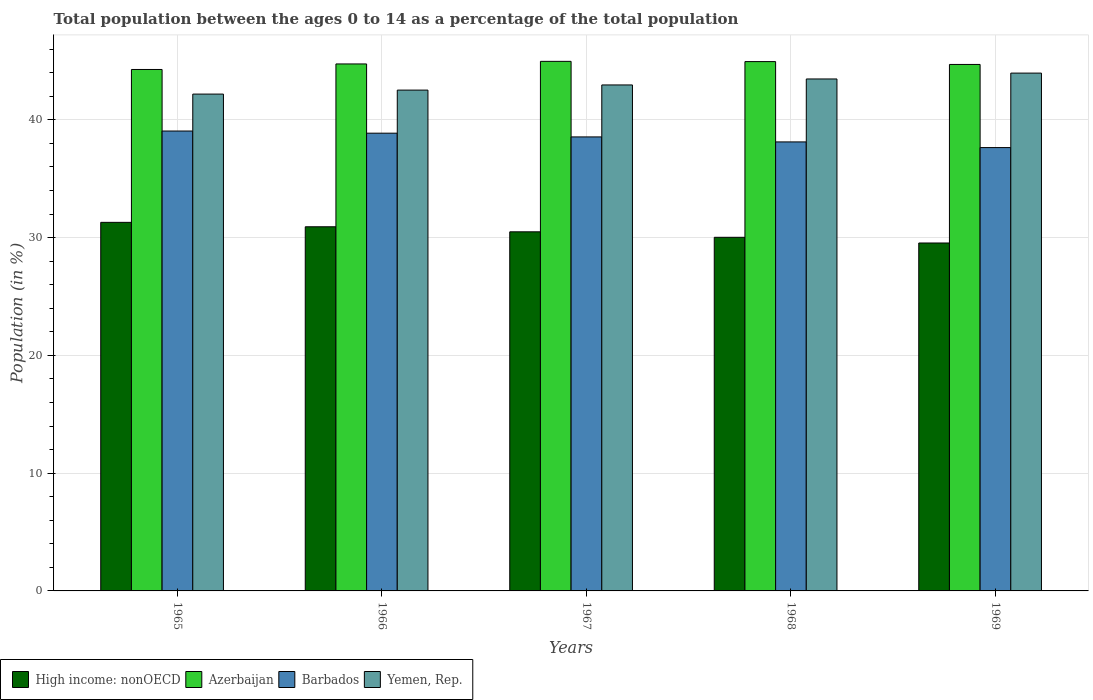How many groups of bars are there?
Your response must be concise. 5. How many bars are there on the 2nd tick from the left?
Provide a succinct answer. 4. What is the label of the 1st group of bars from the left?
Your response must be concise. 1965. What is the percentage of the population ages 0 to 14 in Barbados in 1969?
Provide a short and direct response. 37.65. Across all years, what is the maximum percentage of the population ages 0 to 14 in Barbados?
Your response must be concise. 39.05. Across all years, what is the minimum percentage of the population ages 0 to 14 in Yemen, Rep.?
Provide a succinct answer. 42.19. In which year was the percentage of the population ages 0 to 14 in High income: nonOECD maximum?
Your response must be concise. 1965. In which year was the percentage of the population ages 0 to 14 in Barbados minimum?
Offer a very short reply. 1969. What is the total percentage of the population ages 0 to 14 in Azerbaijan in the graph?
Keep it short and to the point. 223.65. What is the difference between the percentage of the population ages 0 to 14 in Barbados in 1967 and that in 1968?
Your response must be concise. 0.42. What is the difference between the percentage of the population ages 0 to 14 in High income: nonOECD in 1965 and the percentage of the population ages 0 to 14 in Azerbaijan in 1967?
Provide a succinct answer. -13.67. What is the average percentage of the population ages 0 to 14 in High income: nonOECD per year?
Make the answer very short. 30.46. In the year 1966, what is the difference between the percentage of the population ages 0 to 14 in High income: nonOECD and percentage of the population ages 0 to 14 in Barbados?
Ensure brevity in your answer.  -7.95. What is the ratio of the percentage of the population ages 0 to 14 in Yemen, Rep. in 1967 to that in 1968?
Offer a very short reply. 0.99. Is the percentage of the population ages 0 to 14 in Yemen, Rep. in 1965 less than that in 1966?
Ensure brevity in your answer.  Yes. What is the difference between the highest and the second highest percentage of the population ages 0 to 14 in Yemen, Rep.?
Offer a terse response. 0.5. What is the difference between the highest and the lowest percentage of the population ages 0 to 14 in Yemen, Rep.?
Your answer should be very brief. 1.78. In how many years, is the percentage of the population ages 0 to 14 in Azerbaijan greater than the average percentage of the population ages 0 to 14 in Azerbaijan taken over all years?
Your answer should be compact. 3. Is it the case that in every year, the sum of the percentage of the population ages 0 to 14 in High income: nonOECD and percentage of the population ages 0 to 14 in Barbados is greater than the sum of percentage of the population ages 0 to 14 in Azerbaijan and percentage of the population ages 0 to 14 in Yemen, Rep.?
Make the answer very short. No. What does the 4th bar from the left in 1969 represents?
Offer a very short reply. Yemen, Rep. What does the 4th bar from the right in 1967 represents?
Give a very brief answer. High income: nonOECD. Is it the case that in every year, the sum of the percentage of the population ages 0 to 14 in High income: nonOECD and percentage of the population ages 0 to 14 in Azerbaijan is greater than the percentage of the population ages 0 to 14 in Barbados?
Make the answer very short. Yes. How many bars are there?
Provide a short and direct response. 20. Are all the bars in the graph horizontal?
Give a very brief answer. No. How many years are there in the graph?
Provide a succinct answer. 5. Does the graph contain any zero values?
Your answer should be compact. No. Does the graph contain grids?
Keep it short and to the point. Yes. How are the legend labels stacked?
Make the answer very short. Horizontal. What is the title of the graph?
Offer a terse response. Total population between the ages 0 to 14 as a percentage of the total population. What is the label or title of the X-axis?
Your answer should be very brief. Years. What is the label or title of the Y-axis?
Your answer should be compact. Population (in %). What is the Population (in %) of High income: nonOECD in 1965?
Keep it short and to the point. 31.3. What is the Population (in %) of Azerbaijan in 1965?
Keep it short and to the point. 44.28. What is the Population (in %) in Barbados in 1965?
Make the answer very short. 39.05. What is the Population (in %) in Yemen, Rep. in 1965?
Offer a terse response. 42.19. What is the Population (in %) of High income: nonOECD in 1966?
Give a very brief answer. 30.92. What is the Population (in %) in Azerbaijan in 1966?
Offer a terse response. 44.75. What is the Population (in %) in Barbados in 1966?
Make the answer very short. 38.87. What is the Population (in %) in Yemen, Rep. in 1966?
Make the answer very short. 42.53. What is the Population (in %) in High income: nonOECD in 1967?
Keep it short and to the point. 30.49. What is the Population (in %) in Azerbaijan in 1967?
Offer a terse response. 44.97. What is the Population (in %) of Barbados in 1967?
Give a very brief answer. 38.55. What is the Population (in %) in Yemen, Rep. in 1967?
Make the answer very short. 42.97. What is the Population (in %) in High income: nonOECD in 1968?
Give a very brief answer. 30.03. What is the Population (in %) in Azerbaijan in 1968?
Give a very brief answer. 44.95. What is the Population (in %) in Barbados in 1968?
Your answer should be compact. 38.13. What is the Population (in %) in Yemen, Rep. in 1968?
Provide a short and direct response. 43.47. What is the Population (in %) of High income: nonOECD in 1969?
Provide a short and direct response. 29.54. What is the Population (in %) in Azerbaijan in 1969?
Give a very brief answer. 44.71. What is the Population (in %) in Barbados in 1969?
Provide a short and direct response. 37.65. What is the Population (in %) in Yemen, Rep. in 1969?
Keep it short and to the point. 43.97. Across all years, what is the maximum Population (in %) in High income: nonOECD?
Your answer should be compact. 31.3. Across all years, what is the maximum Population (in %) of Azerbaijan?
Ensure brevity in your answer.  44.97. Across all years, what is the maximum Population (in %) of Barbados?
Keep it short and to the point. 39.05. Across all years, what is the maximum Population (in %) of Yemen, Rep.?
Your answer should be very brief. 43.97. Across all years, what is the minimum Population (in %) of High income: nonOECD?
Provide a succinct answer. 29.54. Across all years, what is the minimum Population (in %) of Azerbaijan?
Make the answer very short. 44.28. Across all years, what is the minimum Population (in %) of Barbados?
Your answer should be compact. 37.65. Across all years, what is the minimum Population (in %) of Yemen, Rep.?
Keep it short and to the point. 42.19. What is the total Population (in %) in High income: nonOECD in the graph?
Your answer should be compact. 152.28. What is the total Population (in %) of Azerbaijan in the graph?
Your answer should be very brief. 223.65. What is the total Population (in %) of Barbados in the graph?
Your answer should be very brief. 192.25. What is the total Population (in %) in Yemen, Rep. in the graph?
Give a very brief answer. 215.13. What is the difference between the Population (in %) of High income: nonOECD in 1965 and that in 1966?
Give a very brief answer. 0.38. What is the difference between the Population (in %) in Azerbaijan in 1965 and that in 1966?
Offer a very short reply. -0.47. What is the difference between the Population (in %) in Barbados in 1965 and that in 1966?
Provide a succinct answer. 0.18. What is the difference between the Population (in %) in Yemen, Rep. in 1965 and that in 1966?
Your response must be concise. -0.34. What is the difference between the Population (in %) of High income: nonOECD in 1965 and that in 1967?
Offer a terse response. 0.8. What is the difference between the Population (in %) of Azerbaijan in 1965 and that in 1967?
Offer a terse response. -0.69. What is the difference between the Population (in %) in Barbados in 1965 and that in 1967?
Your answer should be very brief. 0.5. What is the difference between the Population (in %) in Yemen, Rep. in 1965 and that in 1967?
Provide a succinct answer. -0.78. What is the difference between the Population (in %) of High income: nonOECD in 1965 and that in 1968?
Your response must be concise. 1.27. What is the difference between the Population (in %) of Azerbaijan in 1965 and that in 1968?
Keep it short and to the point. -0.67. What is the difference between the Population (in %) in Barbados in 1965 and that in 1968?
Ensure brevity in your answer.  0.93. What is the difference between the Population (in %) of Yemen, Rep. in 1965 and that in 1968?
Provide a succinct answer. -1.28. What is the difference between the Population (in %) of High income: nonOECD in 1965 and that in 1969?
Give a very brief answer. 1.75. What is the difference between the Population (in %) of Azerbaijan in 1965 and that in 1969?
Your answer should be very brief. -0.43. What is the difference between the Population (in %) of Barbados in 1965 and that in 1969?
Ensure brevity in your answer.  1.41. What is the difference between the Population (in %) of Yemen, Rep. in 1965 and that in 1969?
Provide a short and direct response. -1.78. What is the difference between the Population (in %) in High income: nonOECD in 1966 and that in 1967?
Give a very brief answer. 0.43. What is the difference between the Population (in %) of Azerbaijan in 1966 and that in 1967?
Your answer should be compact. -0.22. What is the difference between the Population (in %) in Barbados in 1966 and that in 1967?
Provide a succinct answer. 0.32. What is the difference between the Population (in %) in Yemen, Rep. in 1966 and that in 1967?
Provide a short and direct response. -0.44. What is the difference between the Population (in %) of High income: nonOECD in 1966 and that in 1968?
Make the answer very short. 0.89. What is the difference between the Population (in %) of Azerbaijan in 1966 and that in 1968?
Your response must be concise. -0.2. What is the difference between the Population (in %) in Barbados in 1966 and that in 1968?
Give a very brief answer. 0.74. What is the difference between the Population (in %) in Yemen, Rep. in 1966 and that in 1968?
Your answer should be compact. -0.95. What is the difference between the Population (in %) in High income: nonOECD in 1966 and that in 1969?
Keep it short and to the point. 1.38. What is the difference between the Population (in %) of Azerbaijan in 1966 and that in 1969?
Give a very brief answer. 0.04. What is the difference between the Population (in %) in Barbados in 1966 and that in 1969?
Provide a succinct answer. 1.22. What is the difference between the Population (in %) in Yemen, Rep. in 1966 and that in 1969?
Ensure brevity in your answer.  -1.44. What is the difference between the Population (in %) in High income: nonOECD in 1967 and that in 1968?
Make the answer very short. 0.47. What is the difference between the Population (in %) of Azerbaijan in 1967 and that in 1968?
Offer a very short reply. 0.02. What is the difference between the Population (in %) of Barbados in 1967 and that in 1968?
Offer a very short reply. 0.42. What is the difference between the Population (in %) of Yemen, Rep. in 1967 and that in 1968?
Ensure brevity in your answer.  -0.51. What is the difference between the Population (in %) in High income: nonOECD in 1967 and that in 1969?
Give a very brief answer. 0.95. What is the difference between the Population (in %) in Azerbaijan in 1967 and that in 1969?
Your response must be concise. 0.26. What is the difference between the Population (in %) of Barbados in 1967 and that in 1969?
Make the answer very short. 0.91. What is the difference between the Population (in %) of Yemen, Rep. in 1967 and that in 1969?
Offer a very short reply. -1.01. What is the difference between the Population (in %) in High income: nonOECD in 1968 and that in 1969?
Give a very brief answer. 0.48. What is the difference between the Population (in %) of Azerbaijan in 1968 and that in 1969?
Keep it short and to the point. 0.24. What is the difference between the Population (in %) in Barbados in 1968 and that in 1969?
Your answer should be very brief. 0.48. What is the difference between the Population (in %) in Yemen, Rep. in 1968 and that in 1969?
Your response must be concise. -0.5. What is the difference between the Population (in %) of High income: nonOECD in 1965 and the Population (in %) of Azerbaijan in 1966?
Keep it short and to the point. -13.45. What is the difference between the Population (in %) of High income: nonOECD in 1965 and the Population (in %) of Barbados in 1966?
Ensure brevity in your answer.  -7.57. What is the difference between the Population (in %) of High income: nonOECD in 1965 and the Population (in %) of Yemen, Rep. in 1966?
Your response must be concise. -11.23. What is the difference between the Population (in %) of Azerbaijan in 1965 and the Population (in %) of Barbados in 1966?
Your response must be concise. 5.41. What is the difference between the Population (in %) in Azerbaijan in 1965 and the Population (in %) in Yemen, Rep. in 1966?
Provide a succinct answer. 1.75. What is the difference between the Population (in %) in Barbados in 1965 and the Population (in %) in Yemen, Rep. in 1966?
Your answer should be compact. -3.47. What is the difference between the Population (in %) in High income: nonOECD in 1965 and the Population (in %) in Azerbaijan in 1967?
Offer a terse response. -13.67. What is the difference between the Population (in %) of High income: nonOECD in 1965 and the Population (in %) of Barbados in 1967?
Offer a very short reply. -7.25. What is the difference between the Population (in %) of High income: nonOECD in 1965 and the Population (in %) of Yemen, Rep. in 1967?
Offer a very short reply. -11.67. What is the difference between the Population (in %) in Azerbaijan in 1965 and the Population (in %) in Barbados in 1967?
Make the answer very short. 5.73. What is the difference between the Population (in %) of Azerbaijan in 1965 and the Population (in %) of Yemen, Rep. in 1967?
Ensure brevity in your answer.  1.31. What is the difference between the Population (in %) of Barbados in 1965 and the Population (in %) of Yemen, Rep. in 1967?
Provide a succinct answer. -3.91. What is the difference between the Population (in %) of High income: nonOECD in 1965 and the Population (in %) of Azerbaijan in 1968?
Ensure brevity in your answer.  -13.65. What is the difference between the Population (in %) in High income: nonOECD in 1965 and the Population (in %) in Barbados in 1968?
Your answer should be very brief. -6.83. What is the difference between the Population (in %) of High income: nonOECD in 1965 and the Population (in %) of Yemen, Rep. in 1968?
Your response must be concise. -12.18. What is the difference between the Population (in %) of Azerbaijan in 1965 and the Population (in %) of Barbados in 1968?
Offer a very short reply. 6.15. What is the difference between the Population (in %) in Azerbaijan in 1965 and the Population (in %) in Yemen, Rep. in 1968?
Your answer should be very brief. 0.81. What is the difference between the Population (in %) in Barbados in 1965 and the Population (in %) in Yemen, Rep. in 1968?
Your response must be concise. -4.42. What is the difference between the Population (in %) of High income: nonOECD in 1965 and the Population (in %) of Azerbaijan in 1969?
Keep it short and to the point. -13.41. What is the difference between the Population (in %) in High income: nonOECD in 1965 and the Population (in %) in Barbados in 1969?
Your answer should be very brief. -6.35. What is the difference between the Population (in %) in High income: nonOECD in 1965 and the Population (in %) in Yemen, Rep. in 1969?
Provide a succinct answer. -12.67. What is the difference between the Population (in %) of Azerbaijan in 1965 and the Population (in %) of Barbados in 1969?
Give a very brief answer. 6.63. What is the difference between the Population (in %) in Azerbaijan in 1965 and the Population (in %) in Yemen, Rep. in 1969?
Keep it short and to the point. 0.31. What is the difference between the Population (in %) of Barbados in 1965 and the Population (in %) of Yemen, Rep. in 1969?
Offer a terse response. -4.92. What is the difference between the Population (in %) in High income: nonOECD in 1966 and the Population (in %) in Azerbaijan in 1967?
Your response must be concise. -14.05. What is the difference between the Population (in %) in High income: nonOECD in 1966 and the Population (in %) in Barbados in 1967?
Give a very brief answer. -7.63. What is the difference between the Population (in %) in High income: nonOECD in 1966 and the Population (in %) in Yemen, Rep. in 1967?
Give a very brief answer. -12.04. What is the difference between the Population (in %) in Azerbaijan in 1966 and the Population (in %) in Barbados in 1967?
Your answer should be compact. 6.2. What is the difference between the Population (in %) in Azerbaijan in 1966 and the Population (in %) in Yemen, Rep. in 1967?
Offer a very short reply. 1.78. What is the difference between the Population (in %) in Barbados in 1966 and the Population (in %) in Yemen, Rep. in 1967?
Provide a short and direct response. -4.1. What is the difference between the Population (in %) of High income: nonOECD in 1966 and the Population (in %) of Azerbaijan in 1968?
Offer a very short reply. -14.03. What is the difference between the Population (in %) in High income: nonOECD in 1966 and the Population (in %) in Barbados in 1968?
Your answer should be compact. -7.21. What is the difference between the Population (in %) in High income: nonOECD in 1966 and the Population (in %) in Yemen, Rep. in 1968?
Ensure brevity in your answer.  -12.55. What is the difference between the Population (in %) of Azerbaijan in 1966 and the Population (in %) of Barbados in 1968?
Offer a very short reply. 6.62. What is the difference between the Population (in %) in Azerbaijan in 1966 and the Population (in %) in Yemen, Rep. in 1968?
Offer a very short reply. 1.28. What is the difference between the Population (in %) in Barbados in 1966 and the Population (in %) in Yemen, Rep. in 1968?
Your response must be concise. -4.6. What is the difference between the Population (in %) of High income: nonOECD in 1966 and the Population (in %) of Azerbaijan in 1969?
Offer a terse response. -13.79. What is the difference between the Population (in %) of High income: nonOECD in 1966 and the Population (in %) of Barbados in 1969?
Provide a short and direct response. -6.72. What is the difference between the Population (in %) of High income: nonOECD in 1966 and the Population (in %) of Yemen, Rep. in 1969?
Offer a very short reply. -13.05. What is the difference between the Population (in %) of Azerbaijan in 1966 and the Population (in %) of Barbados in 1969?
Provide a succinct answer. 7.1. What is the difference between the Population (in %) of Azerbaijan in 1966 and the Population (in %) of Yemen, Rep. in 1969?
Your answer should be very brief. 0.78. What is the difference between the Population (in %) of Barbados in 1966 and the Population (in %) of Yemen, Rep. in 1969?
Make the answer very short. -5.1. What is the difference between the Population (in %) of High income: nonOECD in 1967 and the Population (in %) of Azerbaijan in 1968?
Offer a very short reply. -14.45. What is the difference between the Population (in %) in High income: nonOECD in 1967 and the Population (in %) in Barbados in 1968?
Your response must be concise. -7.63. What is the difference between the Population (in %) of High income: nonOECD in 1967 and the Population (in %) of Yemen, Rep. in 1968?
Give a very brief answer. -12.98. What is the difference between the Population (in %) in Azerbaijan in 1967 and the Population (in %) in Barbados in 1968?
Ensure brevity in your answer.  6.84. What is the difference between the Population (in %) of Azerbaijan in 1967 and the Population (in %) of Yemen, Rep. in 1968?
Ensure brevity in your answer.  1.5. What is the difference between the Population (in %) in Barbados in 1967 and the Population (in %) in Yemen, Rep. in 1968?
Offer a very short reply. -4.92. What is the difference between the Population (in %) in High income: nonOECD in 1967 and the Population (in %) in Azerbaijan in 1969?
Your answer should be very brief. -14.21. What is the difference between the Population (in %) of High income: nonOECD in 1967 and the Population (in %) of Barbados in 1969?
Offer a very short reply. -7.15. What is the difference between the Population (in %) in High income: nonOECD in 1967 and the Population (in %) in Yemen, Rep. in 1969?
Provide a short and direct response. -13.48. What is the difference between the Population (in %) in Azerbaijan in 1967 and the Population (in %) in Barbados in 1969?
Provide a succinct answer. 7.32. What is the difference between the Population (in %) in Barbados in 1967 and the Population (in %) in Yemen, Rep. in 1969?
Ensure brevity in your answer.  -5.42. What is the difference between the Population (in %) in High income: nonOECD in 1968 and the Population (in %) in Azerbaijan in 1969?
Offer a terse response. -14.68. What is the difference between the Population (in %) of High income: nonOECD in 1968 and the Population (in %) of Barbados in 1969?
Your answer should be very brief. -7.62. What is the difference between the Population (in %) in High income: nonOECD in 1968 and the Population (in %) in Yemen, Rep. in 1969?
Your answer should be compact. -13.94. What is the difference between the Population (in %) of Azerbaijan in 1968 and the Population (in %) of Barbados in 1969?
Provide a succinct answer. 7.3. What is the difference between the Population (in %) in Azerbaijan in 1968 and the Population (in %) in Yemen, Rep. in 1969?
Your answer should be compact. 0.98. What is the difference between the Population (in %) of Barbados in 1968 and the Population (in %) of Yemen, Rep. in 1969?
Provide a short and direct response. -5.84. What is the average Population (in %) in High income: nonOECD per year?
Offer a very short reply. 30.46. What is the average Population (in %) in Azerbaijan per year?
Your answer should be very brief. 44.73. What is the average Population (in %) of Barbados per year?
Ensure brevity in your answer.  38.45. What is the average Population (in %) of Yemen, Rep. per year?
Keep it short and to the point. 43.03. In the year 1965, what is the difference between the Population (in %) of High income: nonOECD and Population (in %) of Azerbaijan?
Your answer should be very brief. -12.98. In the year 1965, what is the difference between the Population (in %) of High income: nonOECD and Population (in %) of Barbados?
Give a very brief answer. -7.75. In the year 1965, what is the difference between the Population (in %) of High income: nonOECD and Population (in %) of Yemen, Rep.?
Your answer should be very brief. -10.89. In the year 1965, what is the difference between the Population (in %) in Azerbaijan and Population (in %) in Barbados?
Provide a short and direct response. 5.23. In the year 1965, what is the difference between the Population (in %) of Azerbaijan and Population (in %) of Yemen, Rep.?
Ensure brevity in your answer.  2.09. In the year 1965, what is the difference between the Population (in %) in Barbados and Population (in %) in Yemen, Rep.?
Make the answer very short. -3.14. In the year 1966, what is the difference between the Population (in %) of High income: nonOECD and Population (in %) of Azerbaijan?
Your response must be concise. -13.83. In the year 1966, what is the difference between the Population (in %) in High income: nonOECD and Population (in %) in Barbados?
Offer a very short reply. -7.95. In the year 1966, what is the difference between the Population (in %) in High income: nonOECD and Population (in %) in Yemen, Rep.?
Offer a very short reply. -11.61. In the year 1966, what is the difference between the Population (in %) of Azerbaijan and Population (in %) of Barbados?
Provide a succinct answer. 5.88. In the year 1966, what is the difference between the Population (in %) of Azerbaijan and Population (in %) of Yemen, Rep.?
Ensure brevity in your answer.  2.22. In the year 1966, what is the difference between the Population (in %) of Barbados and Population (in %) of Yemen, Rep.?
Give a very brief answer. -3.66. In the year 1967, what is the difference between the Population (in %) of High income: nonOECD and Population (in %) of Azerbaijan?
Ensure brevity in your answer.  -14.47. In the year 1967, what is the difference between the Population (in %) of High income: nonOECD and Population (in %) of Barbados?
Your answer should be compact. -8.06. In the year 1967, what is the difference between the Population (in %) in High income: nonOECD and Population (in %) in Yemen, Rep.?
Keep it short and to the point. -12.47. In the year 1967, what is the difference between the Population (in %) in Azerbaijan and Population (in %) in Barbados?
Make the answer very short. 6.42. In the year 1967, what is the difference between the Population (in %) in Azerbaijan and Population (in %) in Yemen, Rep.?
Your answer should be very brief. 2. In the year 1967, what is the difference between the Population (in %) in Barbados and Population (in %) in Yemen, Rep.?
Provide a short and direct response. -4.41. In the year 1968, what is the difference between the Population (in %) of High income: nonOECD and Population (in %) of Azerbaijan?
Ensure brevity in your answer.  -14.92. In the year 1968, what is the difference between the Population (in %) of High income: nonOECD and Population (in %) of Barbados?
Your answer should be very brief. -8.1. In the year 1968, what is the difference between the Population (in %) of High income: nonOECD and Population (in %) of Yemen, Rep.?
Keep it short and to the point. -13.45. In the year 1968, what is the difference between the Population (in %) of Azerbaijan and Population (in %) of Barbados?
Your answer should be compact. 6.82. In the year 1968, what is the difference between the Population (in %) in Azerbaijan and Population (in %) in Yemen, Rep.?
Provide a succinct answer. 1.47. In the year 1968, what is the difference between the Population (in %) of Barbados and Population (in %) of Yemen, Rep.?
Offer a terse response. -5.35. In the year 1969, what is the difference between the Population (in %) of High income: nonOECD and Population (in %) of Azerbaijan?
Offer a very short reply. -15.16. In the year 1969, what is the difference between the Population (in %) of High income: nonOECD and Population (in %) of Barbados?
Your answer should be compact. -8.1. In the year 1969, what is the difference between the Population (in %) of High income: nonOECD and Population (in %) of Yemen, Rep.?
Keep it short and to the point. -14.43. In the year 1969, what is the difference between the Population (in %) of Azerbaijan and Population (in %) of Barbados?
Give a very brief answer. 7.06. In the year 1969, what is the difference between the Population (in %) in Azerbaijan and Population (in %) in Yemen, Rep.?
Make the answer very short. 0.74. In the year 1969, what is the difference between the Population (in %) in Barbados and Population (in %) in Yemen, Rep.?
Offer a terse response. -6.33. What is the ratio of the Population (in %) of High income: nonOECD in 1965 to that in 1966?
Your response must be concise. 1.01. What is the ratio of the Population (in %) in Azerbaijan in 1965 to that in 1966?
Keep it short and to the point. 0.99. What is the ratio of the Population (in %) in Barbados in 1965 to that in 1966?
Offer a terse response. 1. What is the ratio of the Population (in %) of Yemen, Rep. in 1965 to that in 1966?
Offer a very short reply. 0.99. What is the ratio of the Population (in %) of High income: nonOECD in 1965 to that in 1967?
Offer a very short reply. 1.03. What is the ratio of the Population (in %) in Azerbaijan in 1965 to that in 1967?
Ensure brevity in your answer.  0.98. What is the ratio of the Population (in %) in Barbados in 1965 to that in 1967?
Ensure brevity in your answer.  1.01. What is the ratio of the Population (in %) in Yemen, Rep. in 1965 to that in 1967?
Your answer should be very brief. 0.98. What is the ratio of the Population (in %) in High income: nonOECD in 1965 to that in 1968?
Offer a very short reply. 1.04. What is the ratio of the Population (in %) of Azerbaijan in 1965 to that in 1968?
Provide a succinct answer. 0.99. What is the ratio of the Population (in %) of Barbados in 1965 to that in 1968?
Your answer should be compact. 1.02. What is the ratio of the Population (in %) of Yemen, Rep. in 1965 to that in 1968?
Your answer should be very brief. 0.97. What is the ratio of the Population (in %) of High income: nonOECD in 1965 to that in 1969?
Ensure brevity in your answer.  1.06. What is the ratio of the Population (in %) of Azerbaijan in 1965 to that in 1969?
Ensure brevity in your answer.  0.99. What is the ratio of the Population (in %) in Barbados in 1965 to that in 1969?
Offer a very short reply. 1.04. What is the ratio of the Population (in %) in Yemen, Rep. in 1965 to that in 1969?
Make the answer very short. 0.96. What is the ratio of the Population (in %) of Azerbaijan in 1966 to that in 1967?
Your answer should be compact. 1. What is the ratio of the Population (in %) in Barbados in 1966 to that in 1967?
Provide a short and direct response. 1.01. What is the ratio of the Population (in %) of High income: nonOECD in 1966 to that in 1968?
Keep it short and to the point. 1.03. What is the ratio of the Population (in %) of Barbados in 1966 to that in 1968?
Make the answer very short. 1.02. What is the ratio of the Population (in %) of Yemen, Rep. in 1966 to that in 1968?
Keep it short and to the point. 0.98. What is the ratio of the Population (in %) of High income: nonOECD in 1966 to that in 1969?
Your answer should be very brief. 1.05. What is the ratio of the Population (in %) of Barbados in 1966 to that in 1969?
Your answer should be very brief. 1.03. What is the ratio of the Population (in %) of Yemen, Rep. in 1966 to that in 1969?
Ensure brevity in your answer.  0.97. What is the ratio of the Population (in %) in High income: nonOECD in 1967 to that in 1968?
Give a very brief answer. 1.02. What is the ratio of the Population (in %) in Barbados in 1967 to that in 1968?
Make the answer very short. 1.01. What is the ratio of the Population (in %) in Yemen, Rep. in 1967 to that in 1968?
Make the answer very short. 0.99. What is the ratio of the Population (in %) in High income: nonOECD in 1967 to that in 1969?
Offer a very short reply. 1.03. What is the ratio of the Population (in %) in Azerbaijan in 1967 to that in 1969?
Make the answer very short. 1.01. What is the ratio of the Population (in %) of Barbados in 1967 to that in 1969?
Your response must be concise. 1.02. What is the ratio of the Population (in %) in Yemen, Rep. in 1967 to that in 1969?
Keep it short and to the point. 0.98. What is the ratio of the Population (in %) of High income: nonOECD in 1968 to that in 1969?
Your response must be concise. 1.02. What is the ratio of the Population (in %) in Azerbaijan in 1968 to that in 1969?
Keep it short and to the point. 1.01. What is the ratio of the Population (in %) of Barbados in 1968 to that in 1969?
Make the answer very short. 1.01. What is the ratio of the Population (in %) of Yemen, Rep. in 1968 to that in 1969?
Ensure brevity in your answer.  0.99. What is the difference between the highest and the second highest Population (in %) of High income: nonOECD?
Offer a terse response. 0.38. What is the difference between the highest and the second highest Population (in %) of Azerbaijan?
Your response must be concise. 0.02. What is the difference between the highest and the second highest Population (in %) in Barbados?
Offer a terse response. 0.18. What is the difference between the highest and the second highest Population (in %) of Yemen, Rep.?
Your response must be concise. 0.5. What is the difference between the highest and the lowest Population (in %) of High income: nonOECD?
Your answer should be very brief. 1.75. What is the difference between the highest and the lowest Population (in %) in Azerbaijan?
Keep it short and to the point. 0.69. What is the difference between the highest and the lowest Population (in %) of Barbados?
Offer a terse response. 1.41. What is the difference between the highest and the lowest Population (in %) of Yemen, Rep.?
Provide a succinct answer. 1.78. 